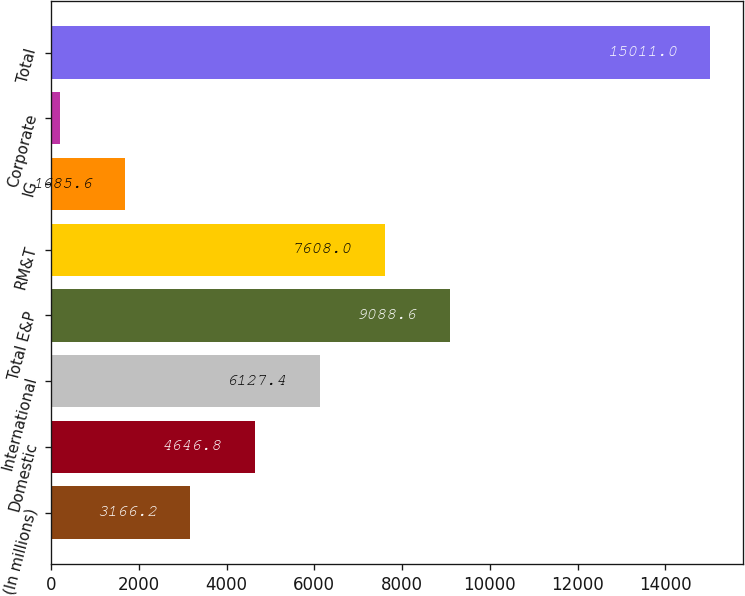Convert chart. <chart><loc_0><loc_0><loc_500><loc_500><bar_chart><fcel>(In millions)<fcel>Domestic<fcel>International<fcel>Total E&P<fcel>RM&T<fcel>IG<fcel>Corporate<fcel>Total<nl><fcel>3166.2<fcel>4646.8<fcel>6127.4<fcel>9088.6<fcel>7608<fcel>1685.6<fcel>205<fcel>15011<nl></chart> 